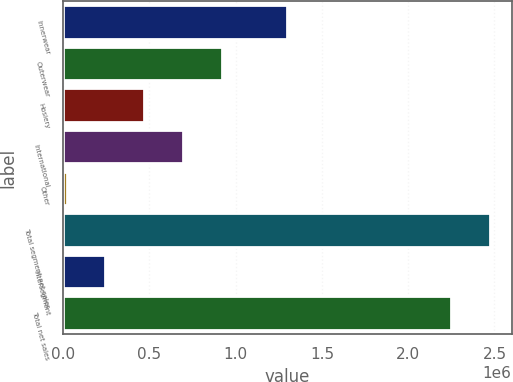<chart> <loc_0><loc_0><loc_500><loc_500><bar_chart><fcel>Innerwear<fcel>Outerwear<fcel>Hosiery<fcel>International<fcel>Other<fcel>Total segment net sales<fcel>Intersegment<fcel>Total net sales<nl><fcel>1.29587e+06<fcel>920965<fcel>470173<fcel>695569<fcel>19381<fcel>2.47587e+06<fcel>244777<fcel>2.25047e+06<nl></chart> 